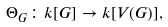<formula> <loc_0><loc_0><loc_500><loc_500>\Theta _ { G } \colon k [ G ] \to k [ V ( G ) ] ,</formula> 